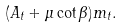<formula> <loc_0><loc_0><loc_500><loc_500>( A _ { t } + \mu \cot \beta ) m _ { t } .</formula> 